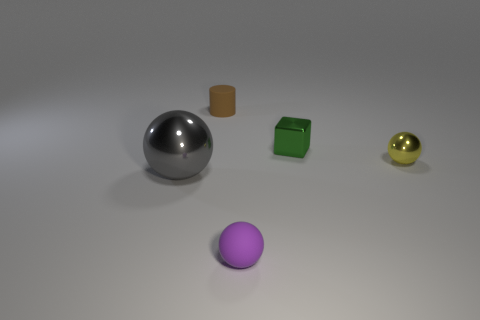How many tiny objects are both behind the big thing and in front of the small brown matte cylinder?
Your response must be concise. 2. Is the number of green things on the left side of the cylinder the same as the number of tiny balls that are in front of the yellow ball?
Make the answer very short. No. Do the tiny matte thing behind the big gray metal thing and the tiny green shiny object have the same shape?
Your response must be concise. No. What shape is the small object that is in front of the shiny ball that is on the right side of the tiny ball in front of the gray metal sphere?
Your answer should be very brief. Sphere. What material is the thing that is behind the small yellow sphere and in front of the tiny brown rubber object?
Ensure brevity in your answer.  Metal. Is the number of small metal spheres less than the number of big purple spheres?
Your response must be concise. No. Does the gray object have the same shape as the rubber object that is behind the large sphere?
Make the answer very short. No. There is a shiny sphere that is on the left side of the yellow shiny sphere; is its size the same as the tiny brown rubber cylinder?
Provide a succinct answer. No. The yellow thing that is the same size as the purple sphere is what shape?
Keep it short and to the point. Sphere. Is the shape of the purple thing the same as the big object?
Your answer should be compact. Yes. 